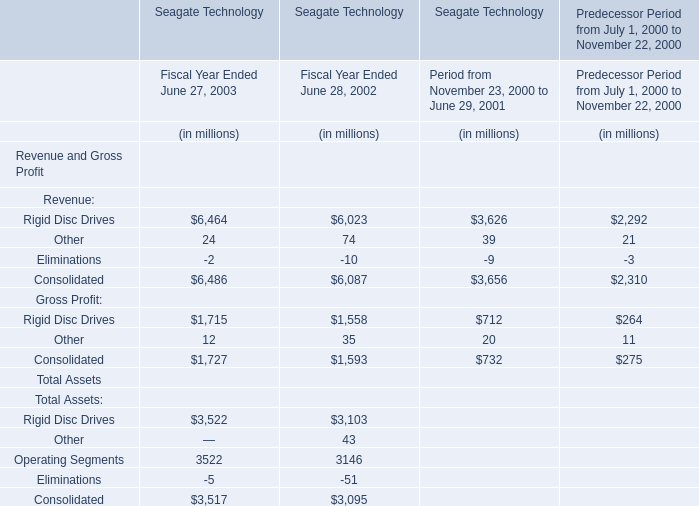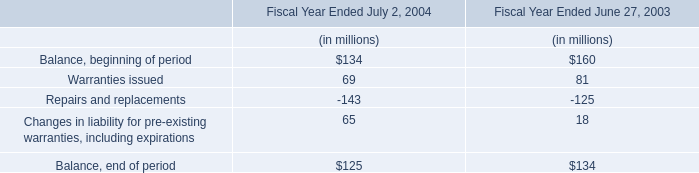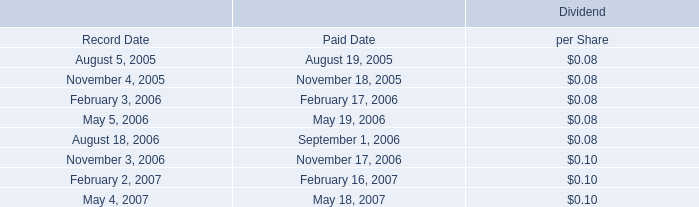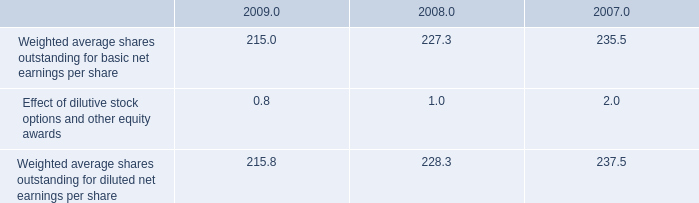what is the percent change in weighted average shares outstanding for basic net earnings per share between 2008 and 2009? 
Computations: ((215.0 - 227.3) / 227.3)
Answer: -0.05411. 